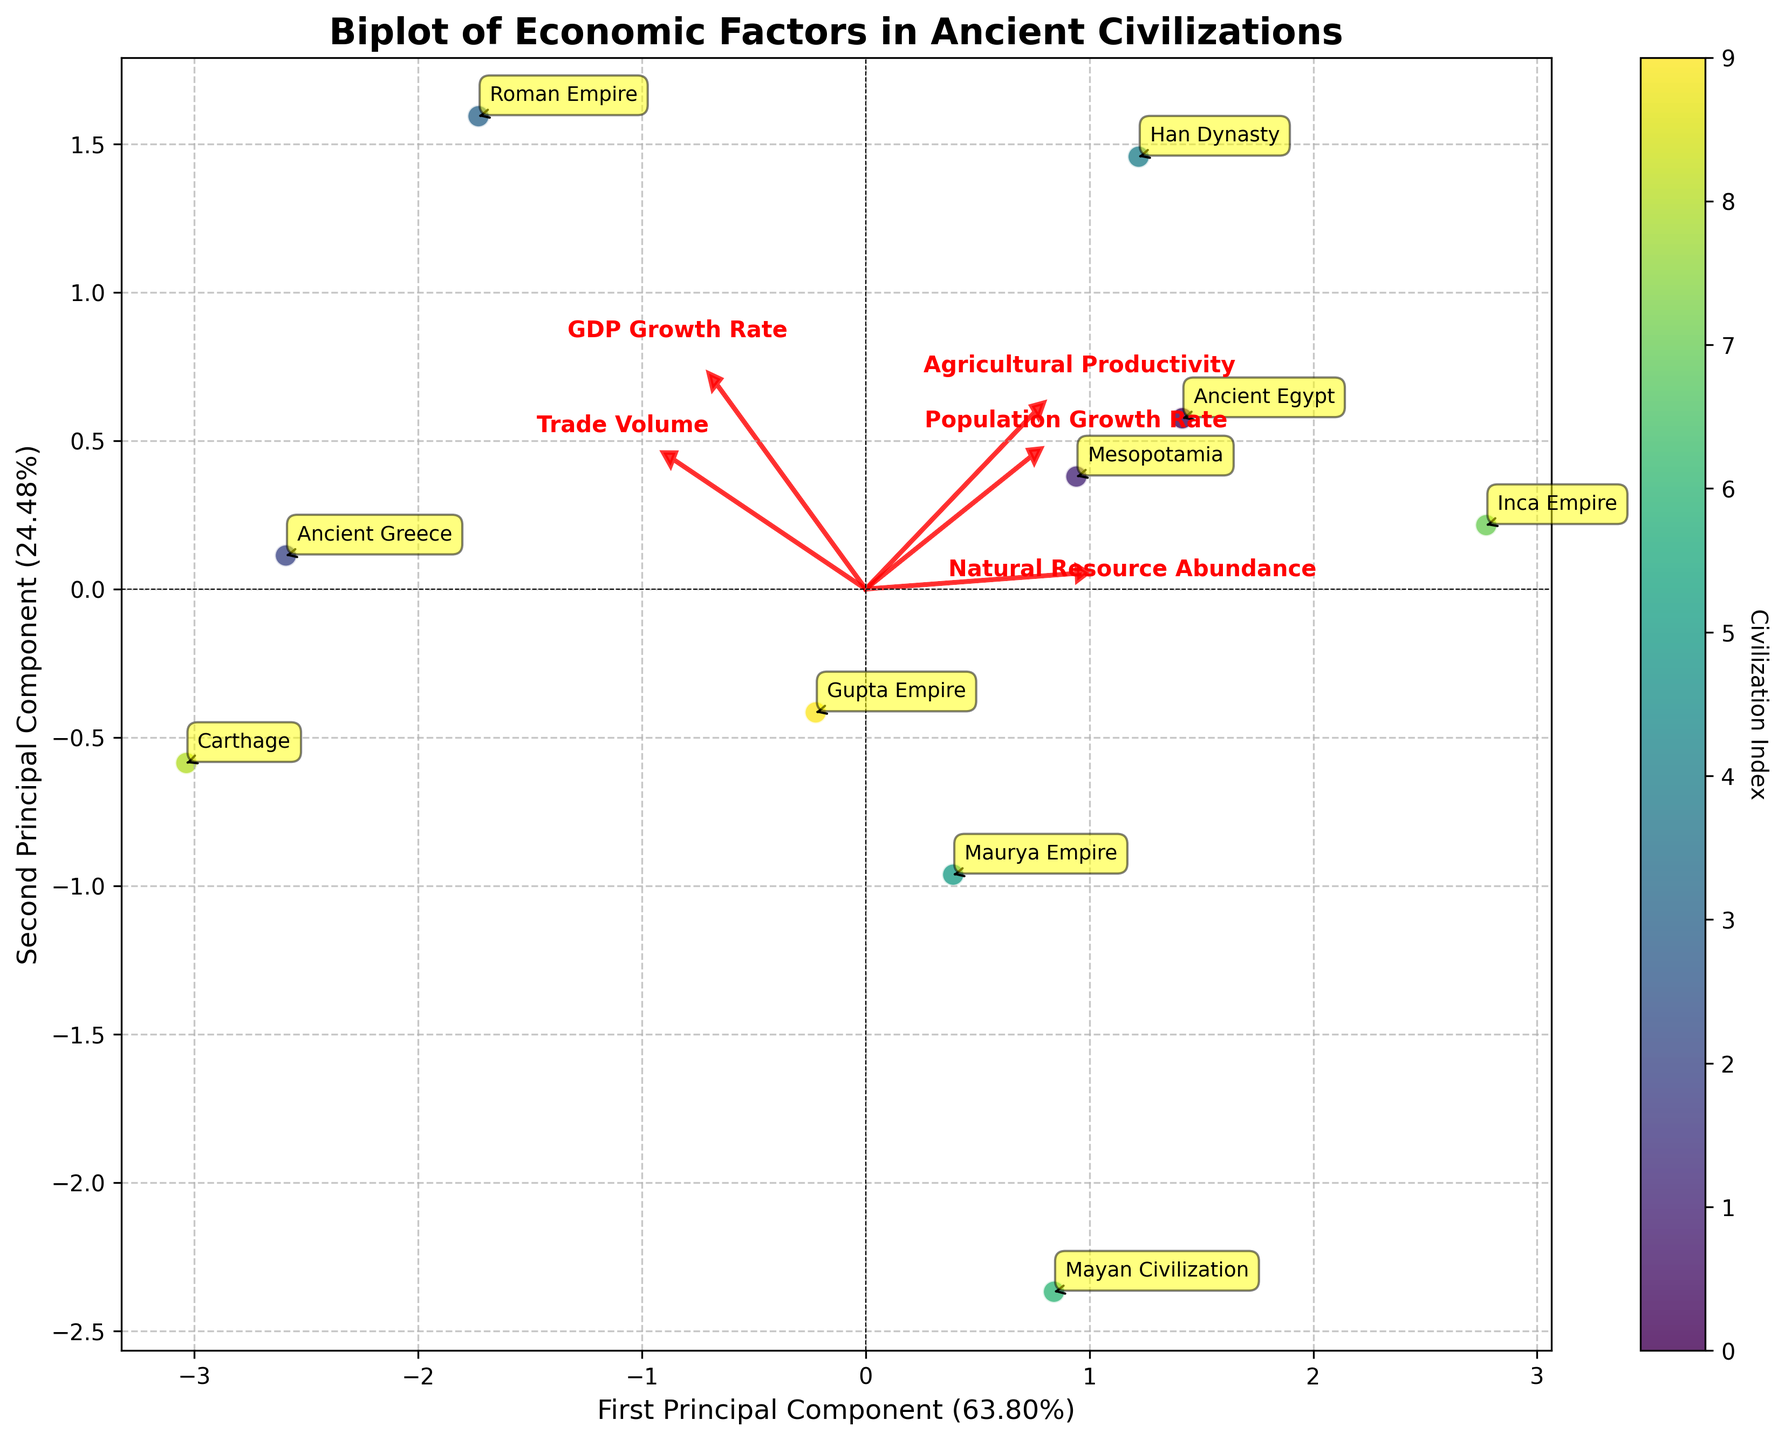Which civilization has the highest GDP Growth Rate in the plot? Look for the civilization that is plotted furthest in the direction of the loading vector for GDP Growth Rate. The Roman Empire is plotted furthest in this direction.
Answer: Roman Empire How many civilizations are plotted in the biplot? Count the number of distinct data points plotted in the figure. Each data point represents a different civilization with its own label. There are 10 civilizations in the plot.
Answer: 10 Which economic factor's vector direction is most closely aligned with the first principal component? Check the direction of each economic factor vector relative to the axis of the first principal component. Trade Volume appears most aligned with the First Principal Component.
Answer: Trade Volume What civilization shows a high value for both GDP Growth Rate and Trade Volume? Identify the civilization plotted furthest in directions of both GDP Growth Rate and Trade Volume vectors. The Roman Empire is plotted near the direction where these vectors converge, indicating high values for both.
Answer: Roman Empire Which Civilization has the highest Natural Resource Abundance? Look for the arrow indicating Natural Resource Abundance and identify the civilization nearest the tip of this arrow. The Inca Empire is closest to this arrow, indicating the highest Natural Resource Abundance.
Answer: Inca Empire What does the length and direction of the vector for Agricultural Productivity imply? Vectors in a biplot indicate the direction and relative extent of the factor's influence. The longer and more horizontally stretched arrow for Agricultural Productivity suggests it's strongly correlated with the first principal component, indicating its notable influence.
Answer: Significant Influence Which civilizations have relatively low Population Growth Rate but high Trade Volume? Look for civilizations that are positioned closer to the Trade Volume arrow but away from the Population Growth Rate arrow. Carthage and Ancient Greece fit this description.
Answer: Carthage and Ancient Greece What civilization is indicated by a color close to the end of the color spectrum on the color bar? Identify the civilization labeled with a color towards the darker or lighter end of the depicted color bar spectrum. The Roman Empire is colored towards one extreme end of the color bar.
Answer: Roman Empire Between which economic factors is there the least visual correlation, based on the angles between their vectors? Vectors that are orthogonally (90 degrees) or close to it indicate little to no correlation. Agricultural Productivity and Natural Resource Abundance vectors are nearly orthogonal.
Answer: Agricultural Productivity and Natural Resource Abundance 